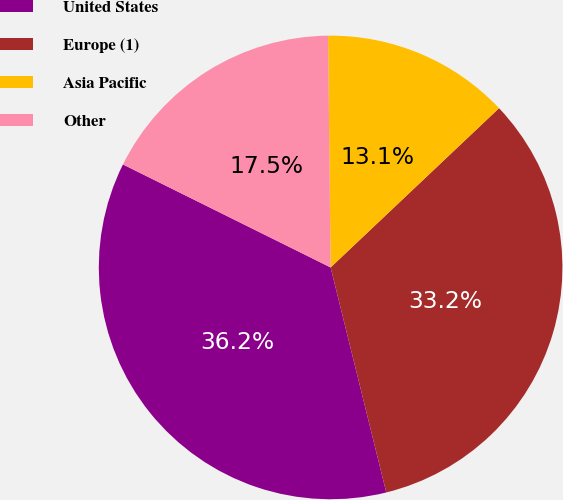Convert chart to OTSL. <chart><loc_0><loc_0><loc_500><loc_500><pie_chart><fcel>United States<fcel>Europe (1)<fcel>Asia Pacific<fcel>Other<nl><fcel>36.19%<fcel>33.2%<fcel>13.12%<fcel>17.5%<nl></chart> 